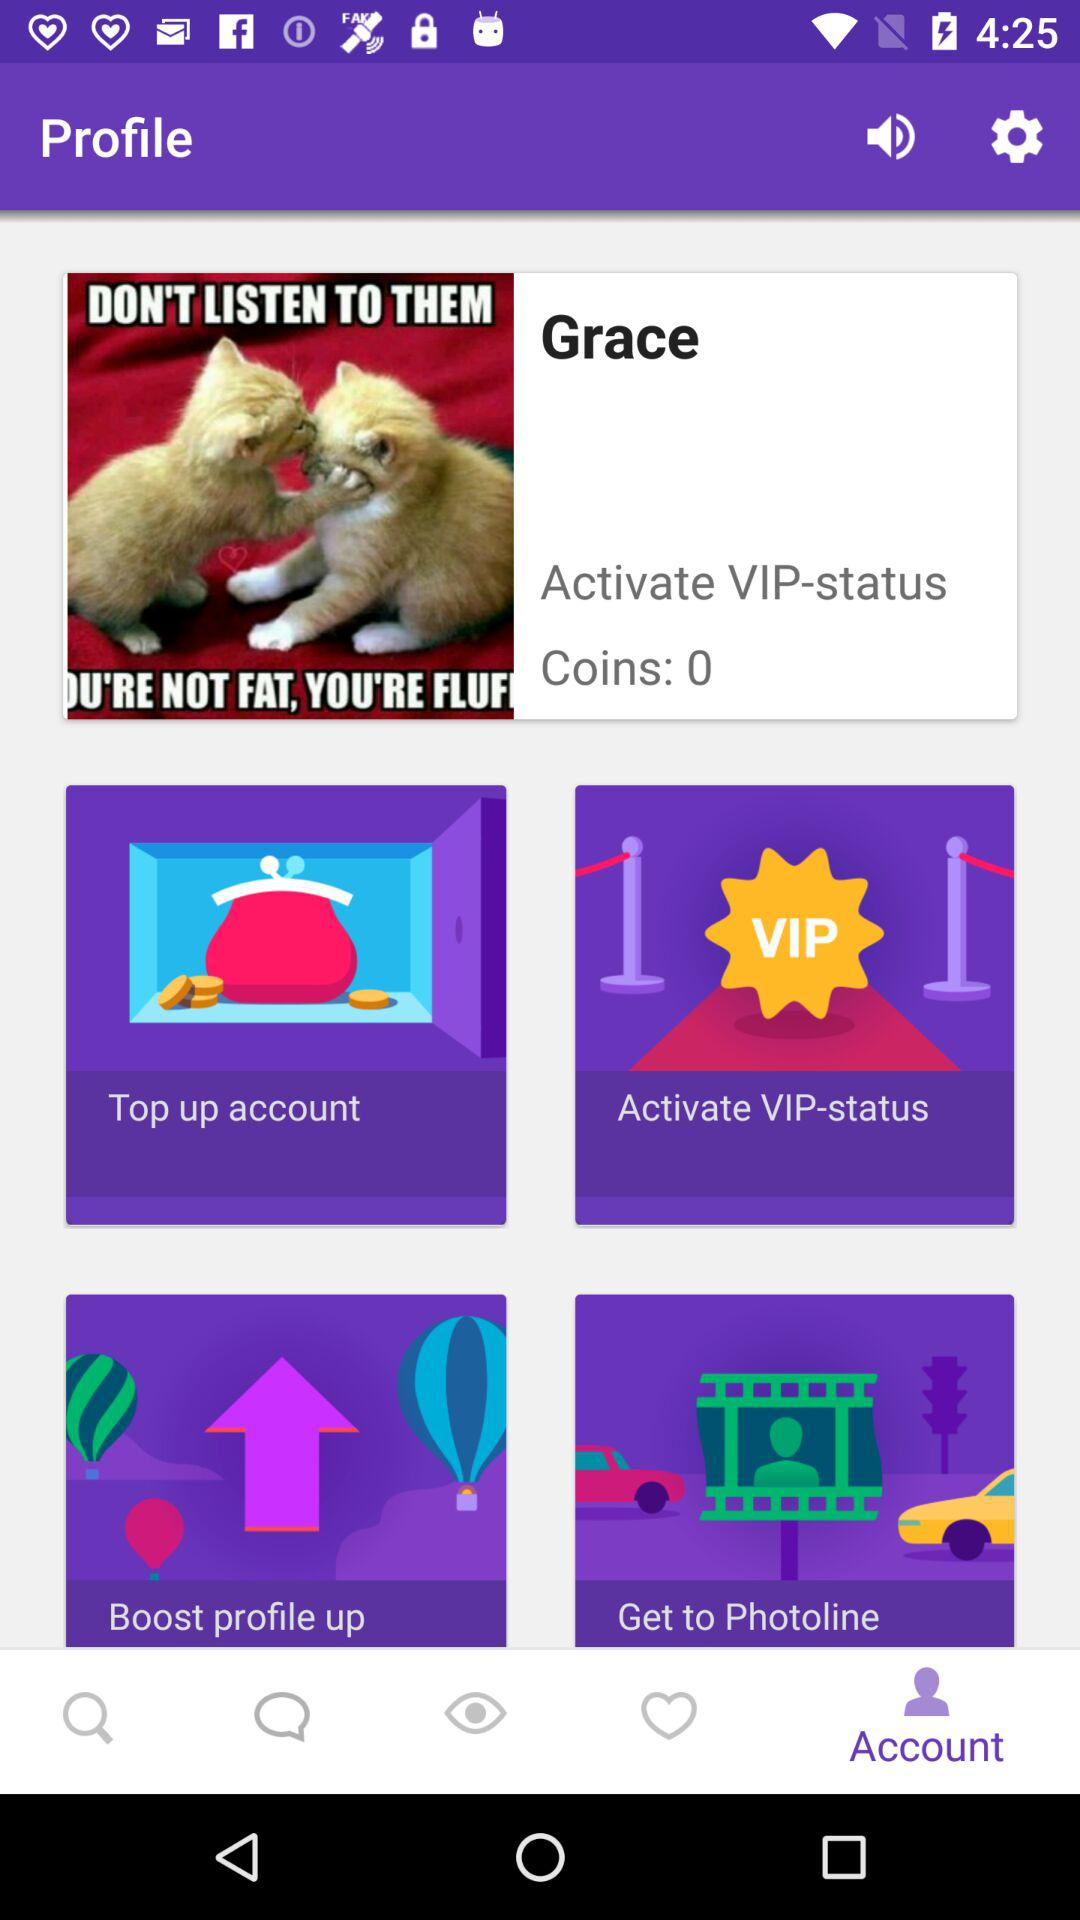Which tab is selected? The selected tab is "Account". 